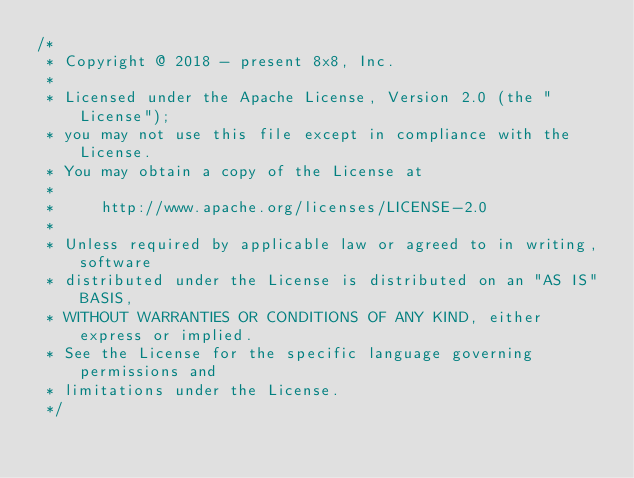Convert code to text. <code><loc_0><loc_0><loc_500><loc_500><_Kotlin_>/*
 * Copyright @ 2018 - present 8x8, Inc.
 *
 * Licensed under the Apache License, Version 2.0 (the "License");
 * you may not use this file except in compliance with the License.
 * You may obtain a copy of the License at
 *
 *     http://www.apache.org/licenses/LICENSE-2.0
 *
 * Unless required by applicable law or agreed to in writing, software
 * distributed under the License is distributed on an "AS IS" BASIS,
 * WITHOUT WARRANTIES OR CONDITIONS OF ANY KIND, either express or implied.
 * See the License for the specific language governing permissions and
 * limitations under the License.
 */
</code> 